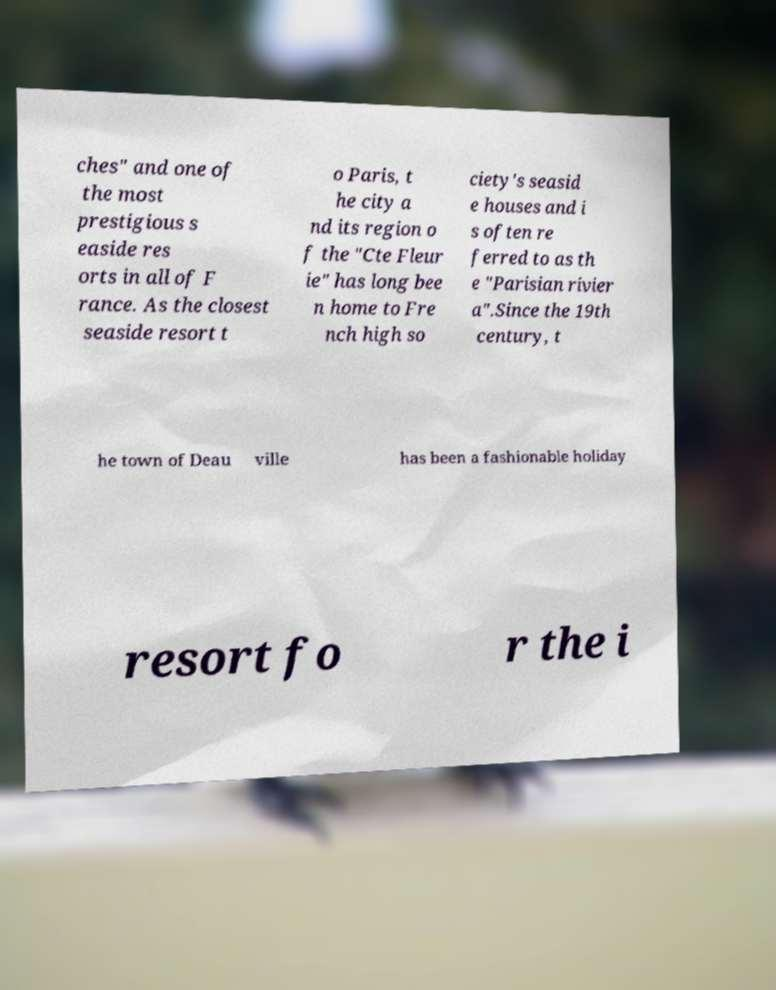Could you assist in decoding the text presented in this image and type it out clearly? ches" and one of the most prestigious s easide res orts in all of F rance. As the closest seaside resort t o Paris, t he city a nd its region o f the "Cte Fleur ie" has long bee n home to Fre nch high so ciety's seasid e houses and i s often re ferred to as th e "Parisian rivier a".Since the 19th century, t he town of Deau ville has been a fashionable holiday resort fo r the i 